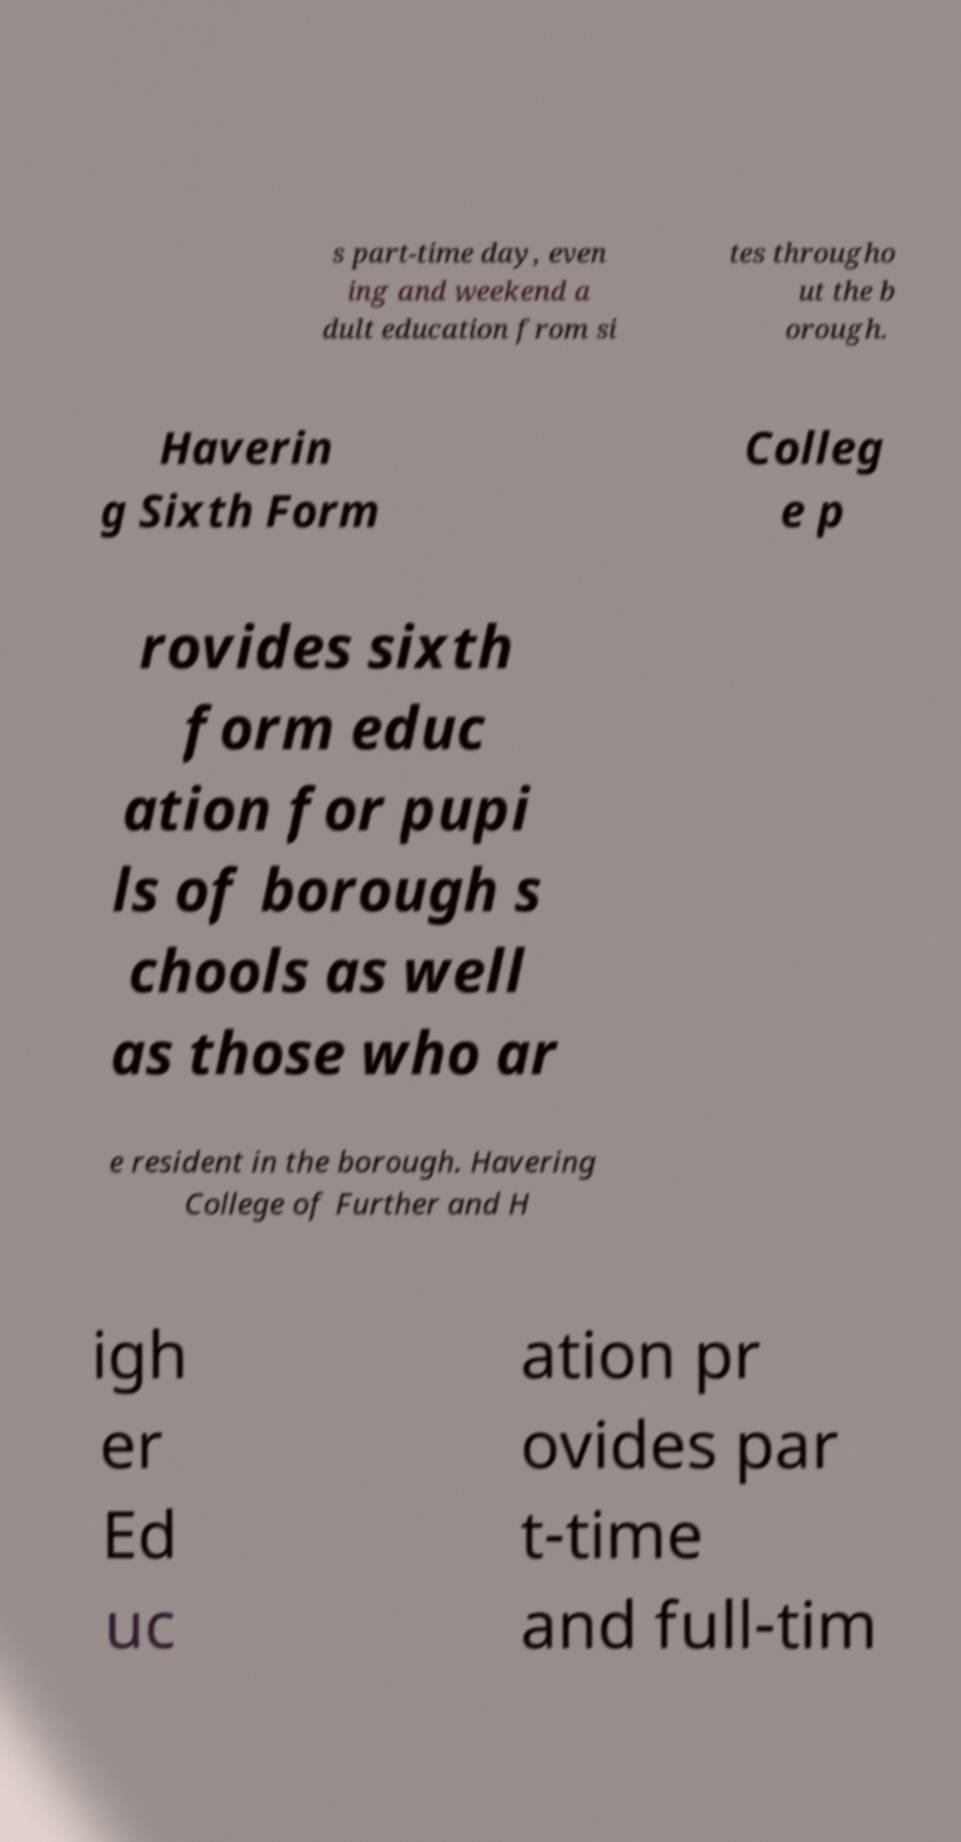I need the written content from this picture converted into text. Can you do that? s part-time day, even ing and weekend a dult education from si tes througho ut the b orough. Haverin g Sixth Form Colleg e p rovides sixth form educ ation for pupi ls of borough s chools as well as those who ar e resident in the borough. Havering College of Further and H igh er Ed uc ation pr ovides par t-time and full-tim 